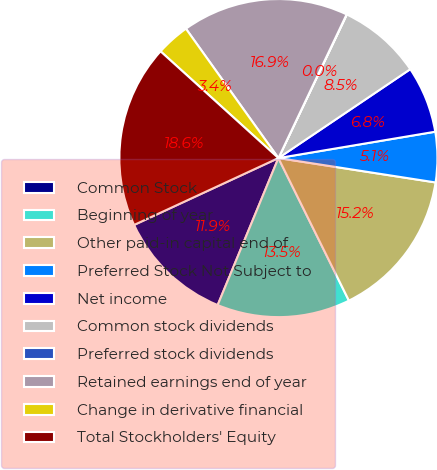<chart> <loc_0><loc_0><loc_500><loc_500><pie_chart><fcel>Common Stock<fcel>Beginning of year<fcel>Other paid-in capital end of<fcel>Preferred Stock Not Subject to<fcel>Net income<fcel>Common stock dividends<fcel>Preferred stock dividends<fcel>Retained earnings end of year<fcel>Change in derivative financial<fcel>Total Stockholders' Equity<nl><fcel>11.86%<fcel>13.55%<fcel>15.24%<fcel>5.1%<fcel>6.79%<fcel>8.48%<fcel>0.03%<fcel>16.93%<fcel>3.41%<fcel>18.62%<nl></chart> 